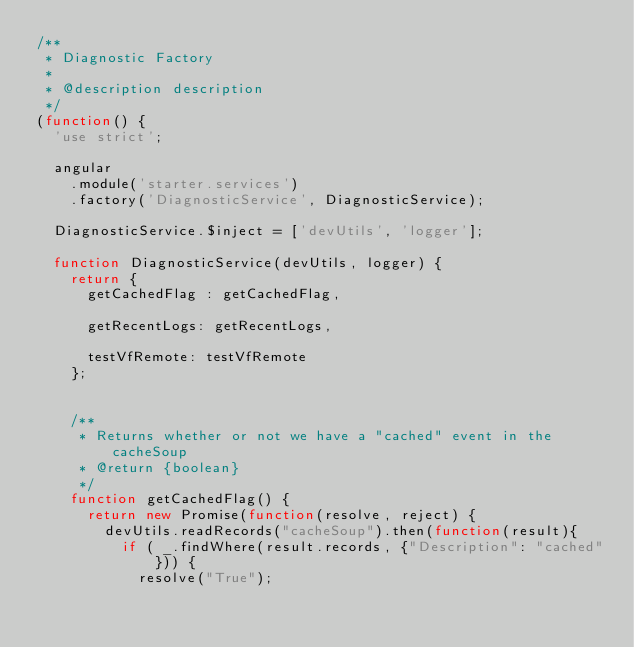<code> <loc_0><loc_0><loc_500><loc_500><_JavaScript_>/**
 * Diagnostic Factory
 *
 * @description description
 */
(function() {
  'use strict';

  angular
    .module('starter.services')
    .factory('DiagnosticService', DiagnosticService);

  DiagnosticService.$inject = ['devUtils', 'logger'];

  function DiagnosticService(devUtils, logger) {
  	return {
  		getCachedFlag : getCachedFlag,

  		getRecentLogs: getRecentLogs,

  		testVfRemote: testVfRemote
	  };


	  /**
	   * Returns whether or not we have a "cached" event in the cacheSoup
	   * @return {boolean}
	   */
	  function getCachedFlag() {
	    return new Promise(function(resolve, reject) {
	    	devUtils.readRecords("cacheSoup").then(function(result){
	    		if ( _.findWhere(result.records, {"Description": "cached"})) {
		    		resolve("True");</code> 